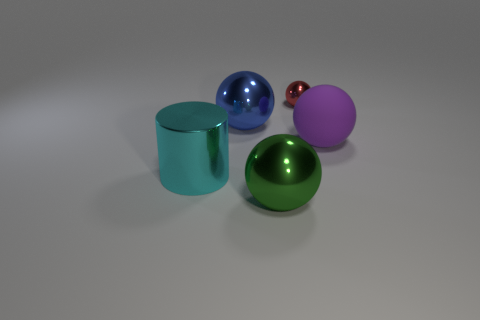Subtract all purple matte balls. How many balls are left? 3 Add 4 metallic cylinders. How many objects exist? 9 Subtract all red balls. How many balls are left? 3 Add 3 large purple objects. How many large purple objects exist? 4 Subtract 0 yellow spheres. How many objects are left? 5 Subtract all balls. How many objects are left? 1 Subtract all green balls. Subtract all gray cylinders. How many balls are left? 3 Subtract all big metal objects. Subtract all blue matte blocks. How many objects are left? 2 Add 4 spheres. How many spheres are left? 8 